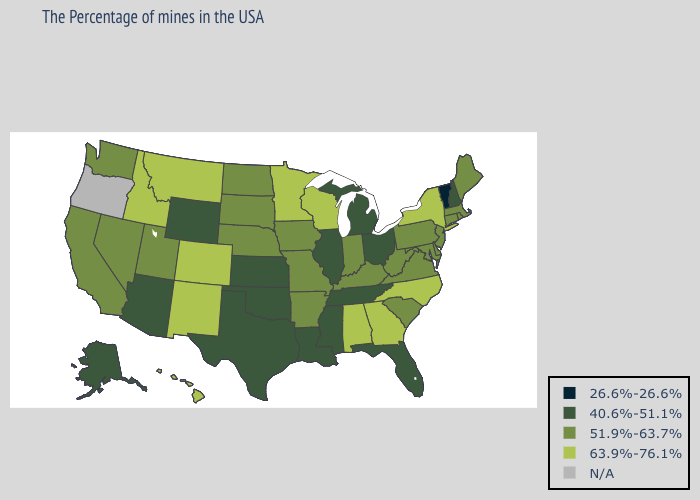What is the value of Alabama?
Keep it brief. 63.9%-76.1%. What is the value of Missouri?
Quick response, please. 51.9%-63.7%. Does the map have missing data?
Give a very brief answer. Yes. Does Florida have the highest value in the USA?
Concise answer only. No. Among the states that border North Carolina , does Tennessee have the lowest value?
Write a very short answer. Yes. Is the legend a continuous bar?
Concise answer only. No. What is the highest value in states that border New Mexico?
Give a very brief answer. 63.9%-76.1%. What is the value of Delaware?
Be succinct. 51.9%-63.7%. Is the legend a continuous bar?
Give a very brief answer. No. Does the map have missing data?
Short answer required. Yes. What is the value of New Mexico?
Answer briefly. 63.9%-76.1%. Name the states that have a value in the range 26.6%-26.6%?
Be succinct. Vermont. Among the states that border Louisiana , which have the lowest value?
Write a very short answer. Mississippi, Texas. 